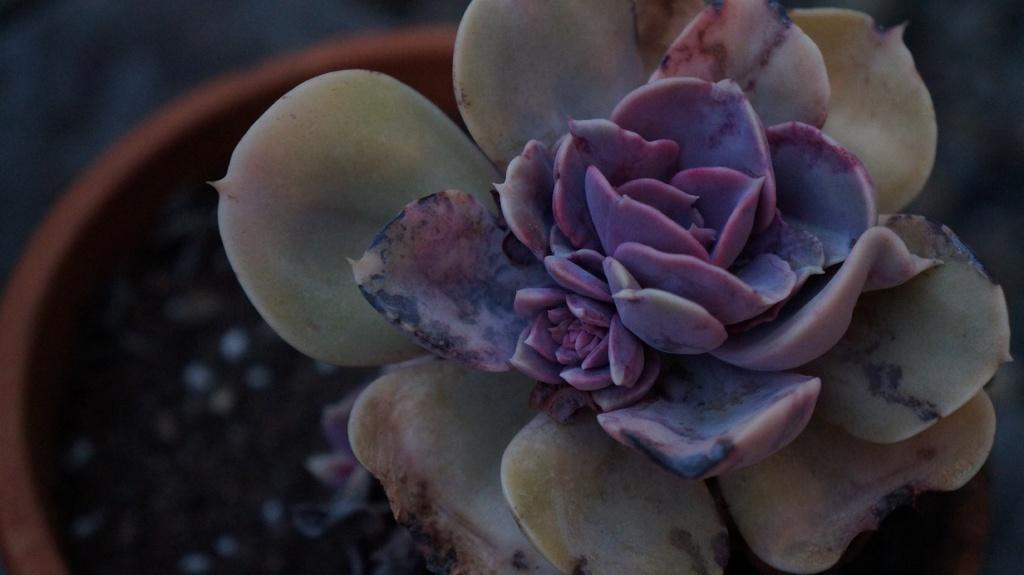What type of living organism can be seen in the image? There is a plant in the image. What type of reward is the plant offering to the viewer in the image? There is no reward offered by the plant in the image, as plants do not have the ability to offer rewards. 